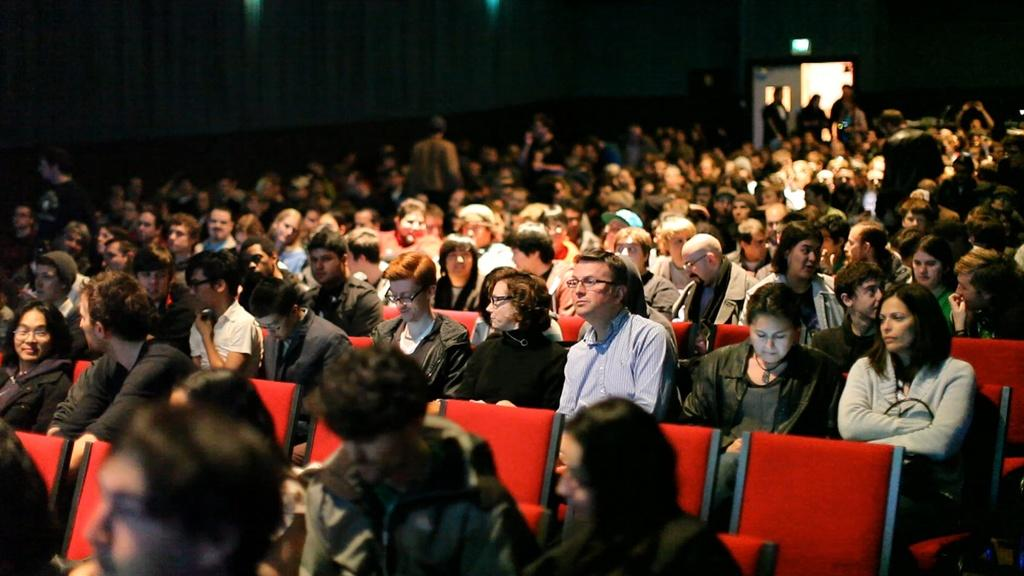What is the main subject of the image? The main subject of the image is a group of people. What are the people in the image doing? The people are sitting on chairs. Can you describe any architectural features in the image? Yes, there is a door visible at the top of the image. How far away is the beetle from the people in the image? There is no beetle present in the image, so it cannot be determined how far away it might be from the people. 